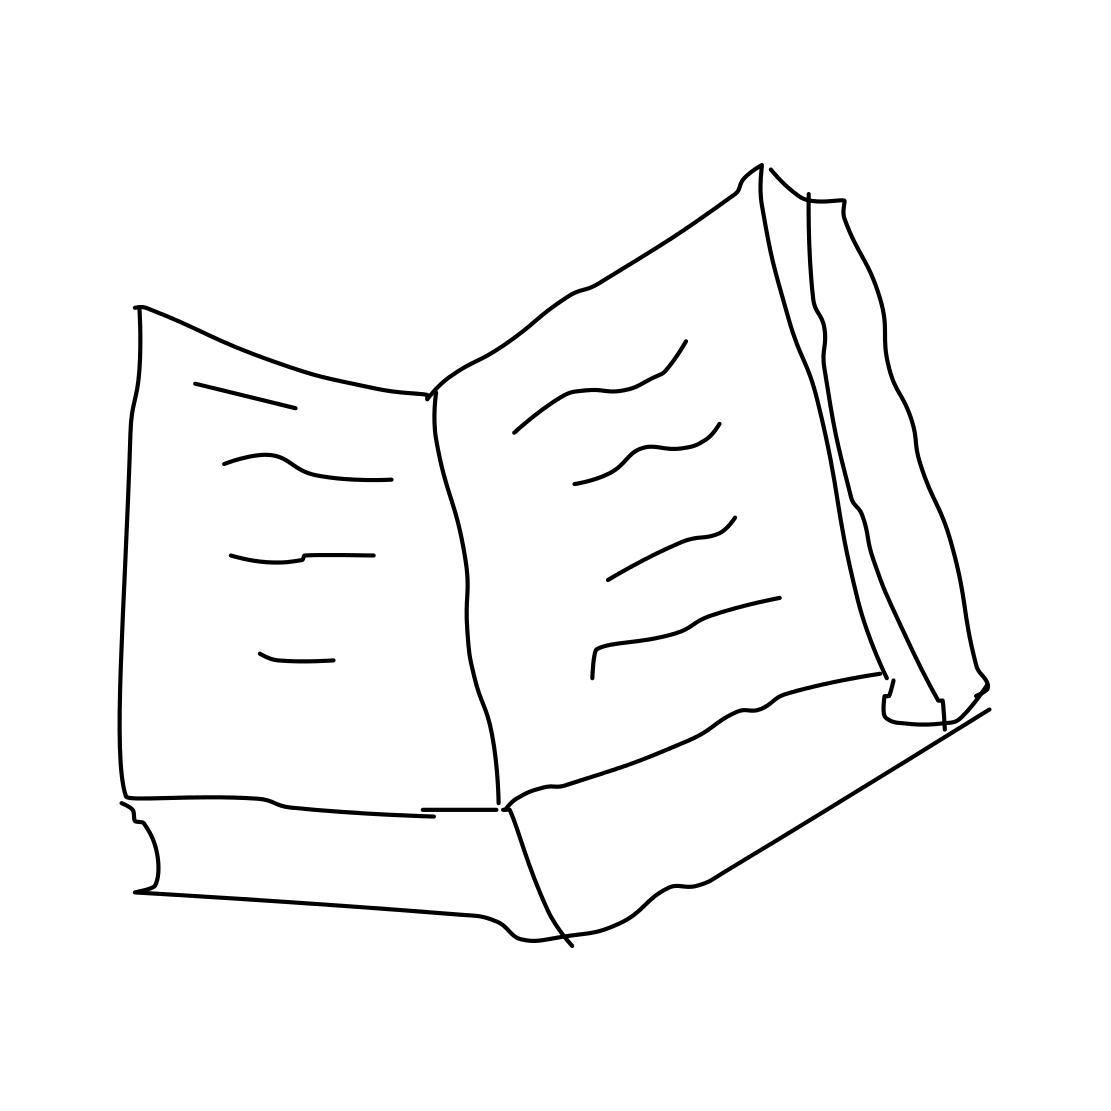Is this a book in the image? Yes, it is. The image shows a simple line drawing of an open book with visible pages and what seems to be text or illustrations on them. 